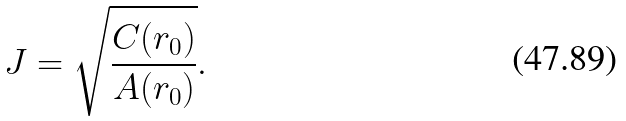Convert formula to latex. <formula><loc_0><loc_0><loc_500><loc_500>J = \sqrt { \frac { C ( r _ { 0 } ) } { A ( r _ { 0 } ) } } .</formula> 